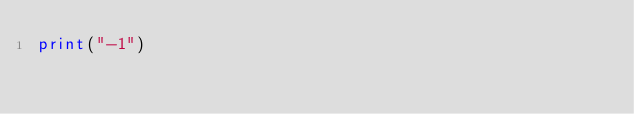<code> <loc_0><loc_0><loc_500><loc_500><_Python_>print("-1")</code> 